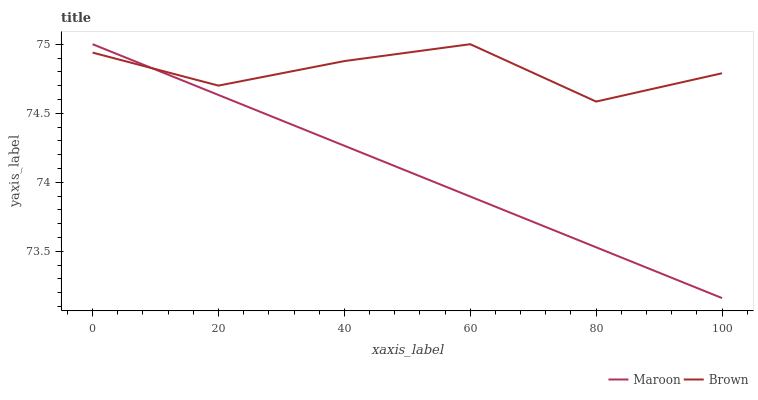Does Maroon have the minimum area under the curve?
Answer yes or no. Yes. Does Brown have the maximum area under the curve?
Answer yes or no. Yes. Does Maroon have the maximum area under the curve?
Answer yes or no. No. Is Maroon the smoothest?
Answer yes or no. Yes. Is Brown the roughest?
Answer yes or no. Yes. Is Maroon the roughest?
Answer yes or no. No. Does Maroon have the highest value?
Answer yes or no. Yes. Does Maroon intersect Brown?
Answer yes or no. Yes. Is Maroon less than Brown?
Answer yes or no. No. Is Maroon greater than Brown?
Answer yes or no. No. 